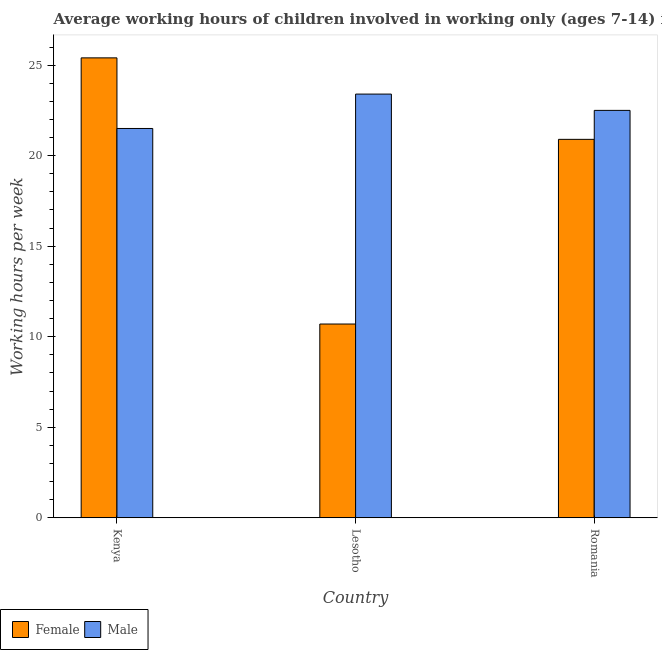How many different coloured bars are there?
Give a very brief answer. 2. How many groups of bars are there?
Your response must be concise. 3. Are the number of bars per tick equal to the number of legend labels?
Your answer should be compact. Yes. What is the label of the 3rd group of bars from the left?
Give a very brief answer. Romania. In how many cases, is the number of bars for a given country not equal to the number of legend labels?
Make the answer very short. 0. What is the average working hour of male children in Romania?
Give a very brief answer. 22.5. Across all countries, what is the maximum average working hour of male children?
Make the answer very short. 23.4. Across all countries, what is the minimum average working hour of male children?
Your response must be concise. 21.5. In which country was the average working hour of male children maximum?
Ensure brevity in your answer.  Lesotho. In which country was the average working hour of male children minimum?
Give a very brief answer. Kenya. What is the total average working hour of female children in the graph?
Offer a terse response. 57. What is the average average working hour of female children per country?
Your answer should be compact. 19. What is the difference between the average working hour of male children and average working hour of female children in Kenya?
Your answer should be very brief. -3.9. In how many countries, is the average working hour of female children greater than 1 hours?
Your response must be concise. 3. Is the average working hour of male children in Kenya less than that in Lesotho?
Keep it short and to the point. Yes. What is the difference between the highest and the second highest average working hour of male children?
Your answer should be compact. 0.9. What is the difference between the highest and the lowest average working hour of male children?
Provide a succinct answer. 1.9. How many bars are there?
Give a very brief answer. 6. Are the values on the major ticks of Y-axis written in scientific E-notation?
Make the answer very short. No. Does the graph contain any zero values?
Provide a succinct answer. No. How many legend labels are there?
Offer a terse response. 2. How are the legend labels stacked?
Keep it short and to the point. Horizontal. What is the title of the graph?
Offer a terse response. Average working hours of children involved in working only (ages 7-14) in 2000. Does "Nonresident" appear as one of the legend labels in the graph?
Your answer should be very brief. No. What is the label or title of the Y-axis?
Your answer should be compact. Working hours per week. What is the Working hours per week in Female in Kenya?
Your answer should be very brief. 25.4. What is the Working hours per week in Male in Kenya?
Your response must be concise. 21.5. What is the Working hours per week in Male in Lesotho?
Keep it short and to the point. 23.4. What is the Working hours per week of Female in Romania?
Make the answer very short. 20.9. Across all countries, what is the maximum Working hours per week in Female?
Offer a very short reply. 25.4. Across all countries, what is the maximum Working hours per week of Male?
Provide a succinct answer. 23.4. Across all countries, what is the minimum Working hours per week of Female?
Keep it short and to the point. 10.7. What is the total Working hours per week of Female in the graph?
Offer a terse response. 57. What is the total Working hours per week of Male in the graph?
Your response must be concise. 67.4. What is the difference between the Working hours per week of Female in Kenya and that in Lesotho?
Provide a short and direct response. 14.7. What is the difference between the Working hours per week in Male in Kenya and that in Lesotho?
Offer a very short reply. -1.9. What is the difference between the Working hours per week in Male in Kenya and that in Romania?
Ensure brevity in your answer.  -1. What is the difference between the Working hours per week of Male in Lesotho and that in Romania?
Your answer should be compact. 0.9. What is the difference between the Working hours per week of Female in Kenya and the Working hours per week of Male in Romania?
Keep it short and to the point. 2.9. What is the difference between the Working hours per week of Female in Lesotho and the Working hours per week of Male in Romania?
Provide a short and direct response. -11.8. What is the average Working hours per week in Female per country?
Make the answer very short. 19. What is the average Working hours per week in Male per country?
Offer a terse response. 22.47. What is the difference between the Working hours per week of Female and Working hours per week of Male in Lesotho?
Your answer should be compact. -12.7. What is the ratio of the Working hours per week of Female in Kenya to that in Lesotho?
Provide a succinct answer. 2.37. What is the ratio of the Working hours per week in Male in Kenya to that in Lesotho?
Ensure brevity in your answer.  0.92. What is the ratio of the Working hours per week of Female in Kenya to that in Romania?
Your response must be concise. 1.22. What is the ratio of the Working hours per week of Male in Kenya to that in Romania?
Offer a terse response. 0.96. What is the ratio of the Working hours per week of Female in Lesotho to that in Romania?
Offer a very short reply. 0.51. What is the difference between the highest and the second highest Working hours per week of Female?
Provide a short and direct response. 4.5. What is the difference between the highest and the lowest Working hours per week in Female?
Offer a terse response. 14.7. What is the difference between the highest and the lowest Working hours per week in Male?
Give a very brief answer. 1.9. 